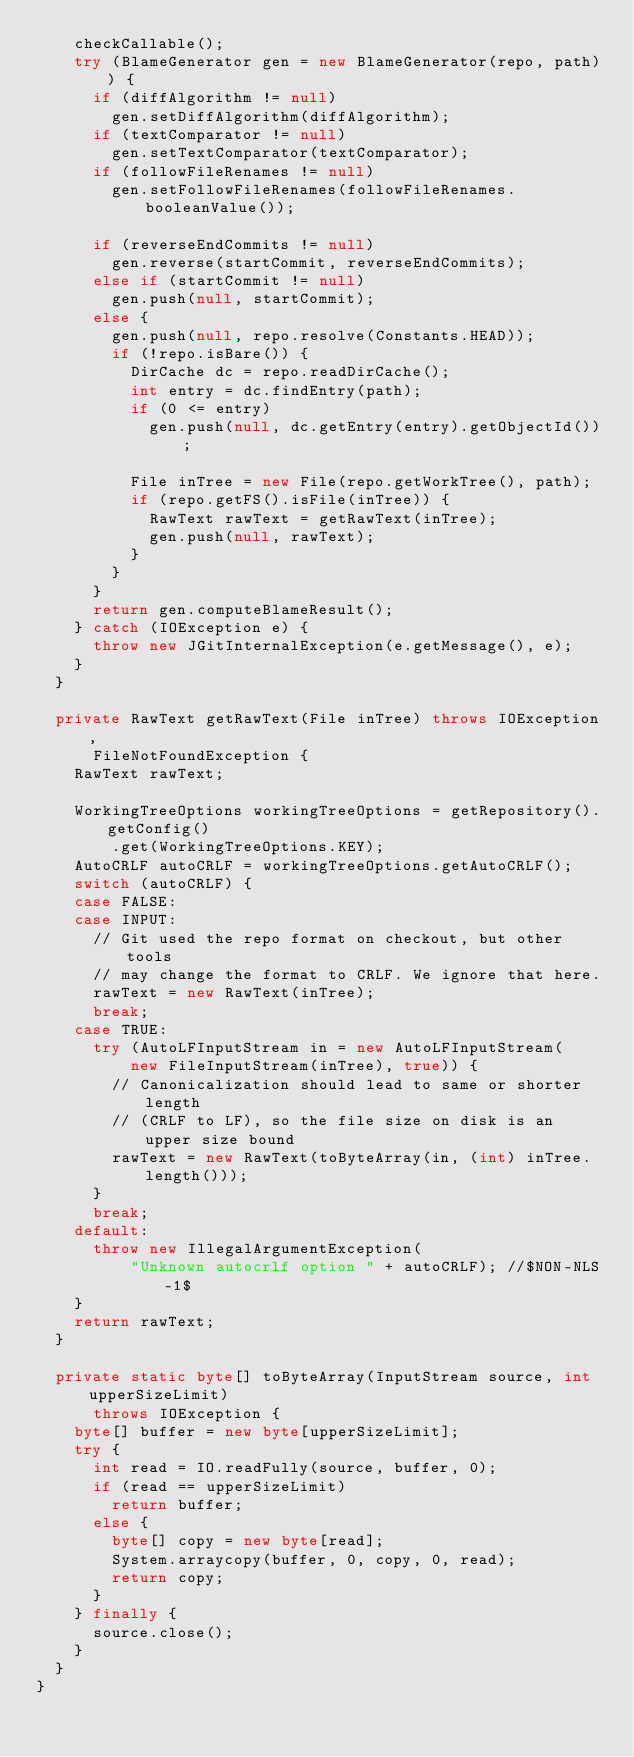<code> <loc_0><loc_0><loc_500><loc_500><_Java_>		checkCallable();
		try (BlameGenerator gen = new BlameGenerator(repo, path)) {
			if (diffAlgorithm != null)
				gen.setDiffAlgorithm(diffAlgorithm);
			if (textComparator != null)
				gen.setTextComparator(textComparator);
			if (followFileRenames != null)
				gen.setFollowFileRenames(followFileRenames.booleanValue());

			if (reverseEndCommits != null)
				gen.reverse(startCommit, reverseEndCommits);
			else if (startCommit != null)
				gen.push(null, startCommit);
			else {
				gen.push(null, repo.resolve(Constants.HEAD));
				if (!repo.isBare()) {
					DirCache dc = repo.readDirCache();
					int entry = dc.findEntry(path);
					if (0 <= entry)
						gen.push(null, dc.getEntry(entry).getObjectId());

					File inTree = new File(repo.getWorkTree(), path);
					if (repo.getFS().isFile(inTree)) {
						RawText rawText = getRawText(inTree);
						gen.push(null, rawText);
					}
				}
			}
			return gen.computeBlameResult();
		} catch (IOException e) {
			throw new JGitInternalException(e.getMessage(), e);
		}
	}

	private RawText getRawText(File inTree) throws IOException,
			FileNotFoundException {
		RawText rawText;

		WorkingTreeOptions workingTreeOptions = getRepository().getConfig()
				.get(WorkingTreeOptions.KEY);
		AutoCRLF autoCRLF = workingTreeOptions.getAutoCRLF();
		switch (autoCRLF) {
		case FALSE:
		case INPUT:
			// Git used the repo format on checkout, but other tools
			// may change the format to CRLF. We ignore that here.
			rawText = new RawText(inTree);
			break;
		case TRUE:
			try (AutoLFInputStream in = new AutoLFInputStream(
					new FileInputStream(inTree), true)) {
				// Canonicalization should lead to same or shorter length
				// (CRLF to LF), so the file size on disk is an upper size bound
				rawText = new RawText(toByteArray(in, (int) inTree.length()));
			}
			break;
		default:
			throw new IllegalArgumentException(
					"Unknown autocrlf option " + autoCRLF); //$NON-NLS-1$
		}
		return rawText;
	}

	private static byte[] toByteArray(InputStream source, int upperSizeLimit)
			throws IOException {
		byte[] buffer = new byte[upperSizeLimit];
		try {
			int read = IO.readFully(source, buffer, 0);
			if (read == upperSizeLimit)
				return buffer;
			else {
				byte[] copy = new byte[read];
				System.arraycopy(buffer, 0, copy, 0, read);
				return copy;
			}
		} finally {
			source.close();
		}
	}
}
</code> 